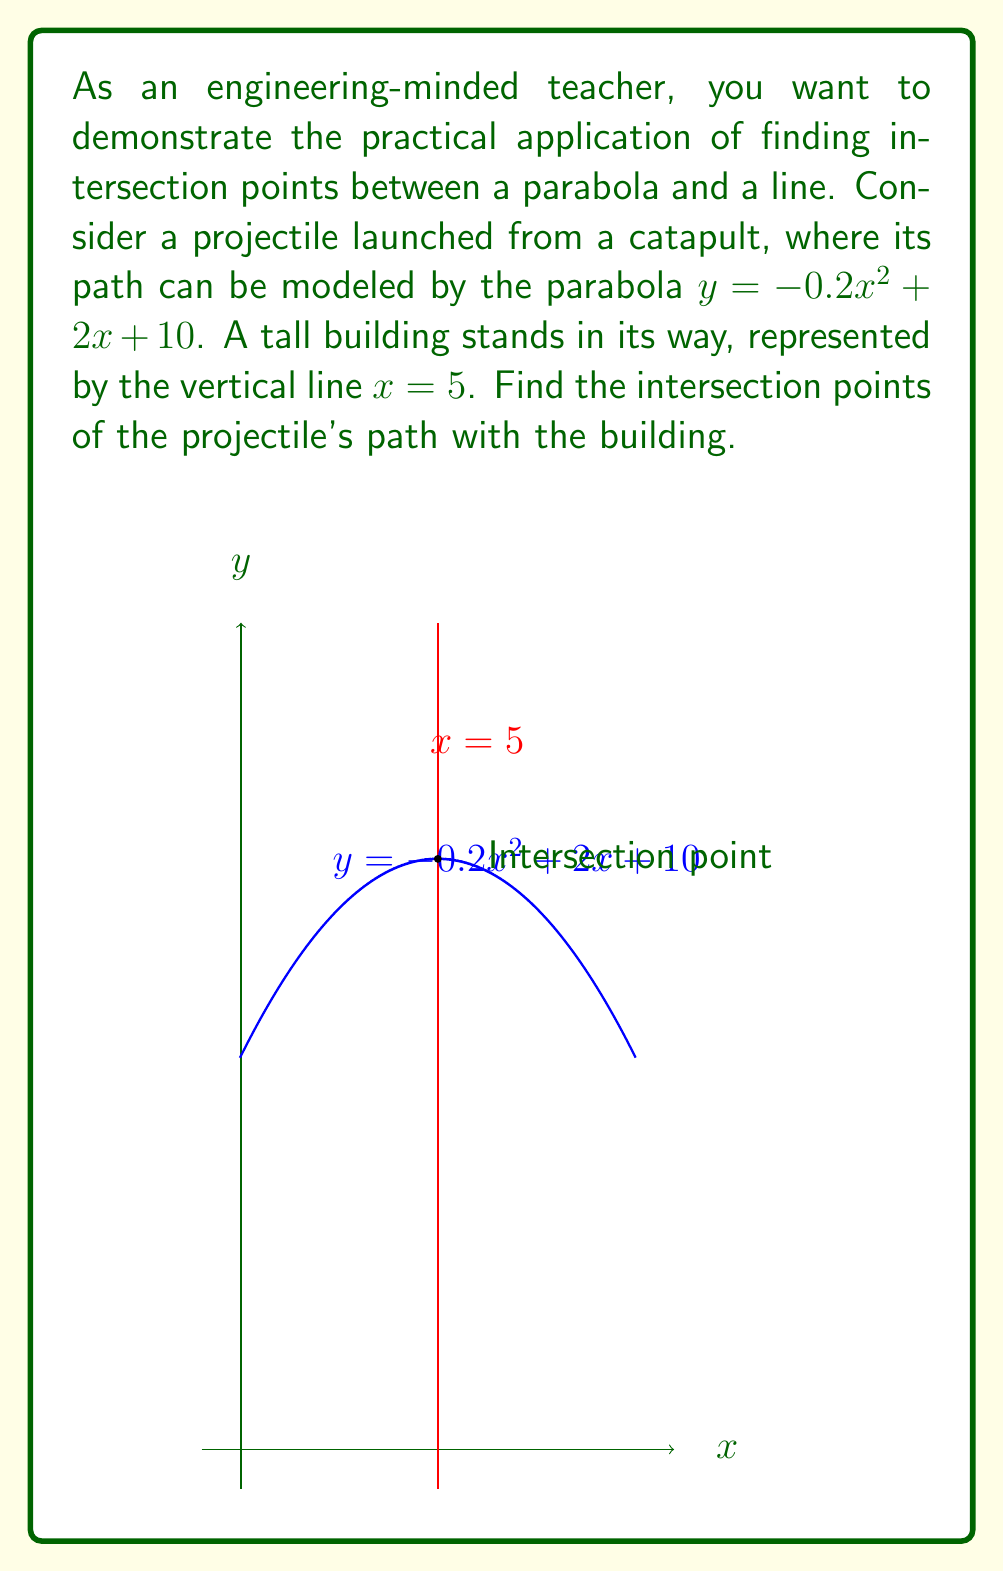Provide a solution to this math problem. Let's approach this step-by-step:

1) The parabola equation is $y = -0.2x^2 + 2x + 10$
   The line equation is $x = 5$

2) To find the intersection points, we substitute $x = 5$ into the parabola equation:

   $y = -0.2(5)^2 + 2(5) + 10$

3) Let's calculate this:
   $y = -0.2(25) + 10 + 10$
   $y = -5 + 10 + 10$
   $y = 15$

4) Therefore, the parabola intersects the line at two points:
   $(5, 15)$ and $(5, 15)$

5) In this case, the two points are identical because the parabola touches the line at exactly one point, known as a tangent point.
Answer: $(5, 15)$ 